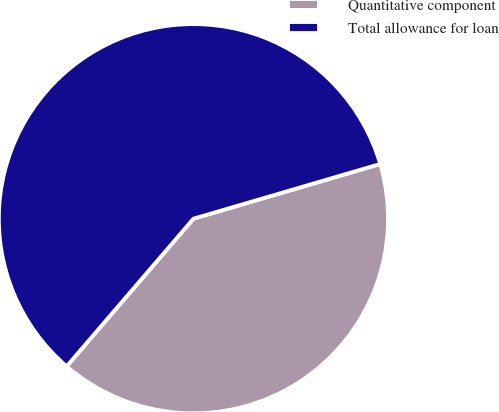<chart> <loc_0><loc_0><loc_500><loc_500><pie_chart><fcel>Quantitative component<fcel>Total allowance for loan<nl><fcel>40.83%<fcel>59.17%<nl></chart> 